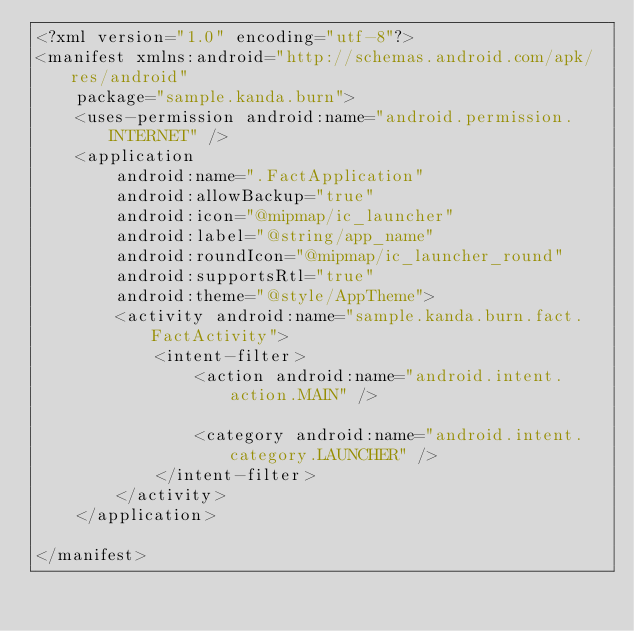<code> <loc_0><loc_0><loc_500><loc_500><_XML_><?xml version="1.0" encoding="utf-8"?>
<manifest xmlns:android="http://schemas.android.com/apk/res/android"
    package="sample.kanda.burn">
    <uses-permission android:name="android.permission.INTERNET" />
    <application
        android:name=".FactApplication"
        android:allowBackup="true"
        android:icon="@mipmap/ic_launcher"
        android:label="@string/app_name"
        android:roundIcon="@mipmap/ic_launcher_round"
        android:supportsRtl="true"
        android:theme="@style/AppTheme">
        <activity android:name="sample.kanda.burn.fact.FactActivity">
            <intent-filter>
                <action android:name="android.intent.action.MAIN" />

                <category android:name="android.intent.category.LAUNCHER" />
            </intent-filter>
        </activity>
    </application>

</manifest></code> 